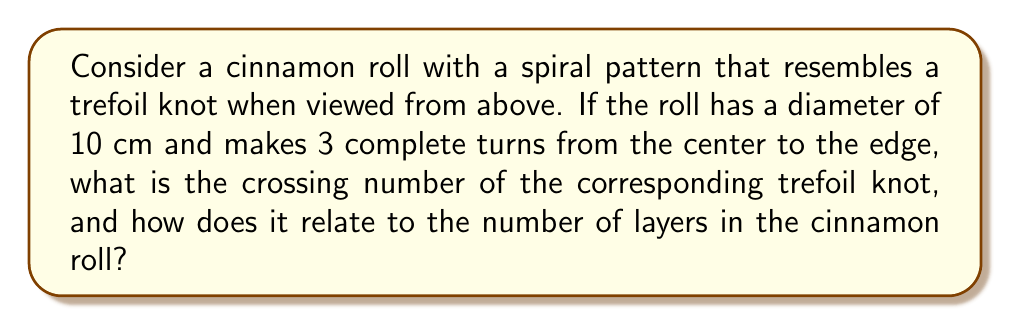Solve this math problem. Let's approach this step-by-step:

1) First, we need to understand the properties of a trefoil knot:
   - A trefoil knot is the simplest non-trivial knot.
   - It has a crossing number of 3, meaning it has three crossings in its minimal diagram.

2) Now, let's analyze the cinnamon roll:
   - The roll makes 3 complete turns from center to edge.
   - Each turn can be considered as one "strand" of the knot.

3) In a trefoil knot, each strand crosses over the other two strands once:
   - Strand 1 crosses over Strand 2
   - Strand 2 crosses over Strand 3
   - Strand 3 crosses over Strand 1

4) This gives us 3 crossings in total, which matches the crossing number of a trefoil knot.

5) Relating this to the layers of the cinnamon roll:
   - Each crossing in the knot corresponds to a layer in the roll where one spiral passes over another.
   - With 3 crossings, we have 3 distinct layers in the roll.

6) We can visualize this mathematically:
   Let $f(r,\theta)$ represent the height of the roll at radius $r$ and angle $\theta$.
   $$f(r,\theta) = h \cdot (\frac{\theta}{2\pi} + \frac{r}{R})$$
   Where $h$ is the height of one layer, $R$ is the radius of the roll, and $\theta$ ranges from 0 to $6\pi$ (3 full turns).

7) The number of layers (L) equals the number of crossings (C) in the trefoil knot:
   $$L = C = 3$$

Therefore, the crossing number of the trefoil knot (3) directly corresponds to the number of distinct layers in the cinnamon roll.
Answer: Crossing number: 3; Equal to number of distinct layers in roll 